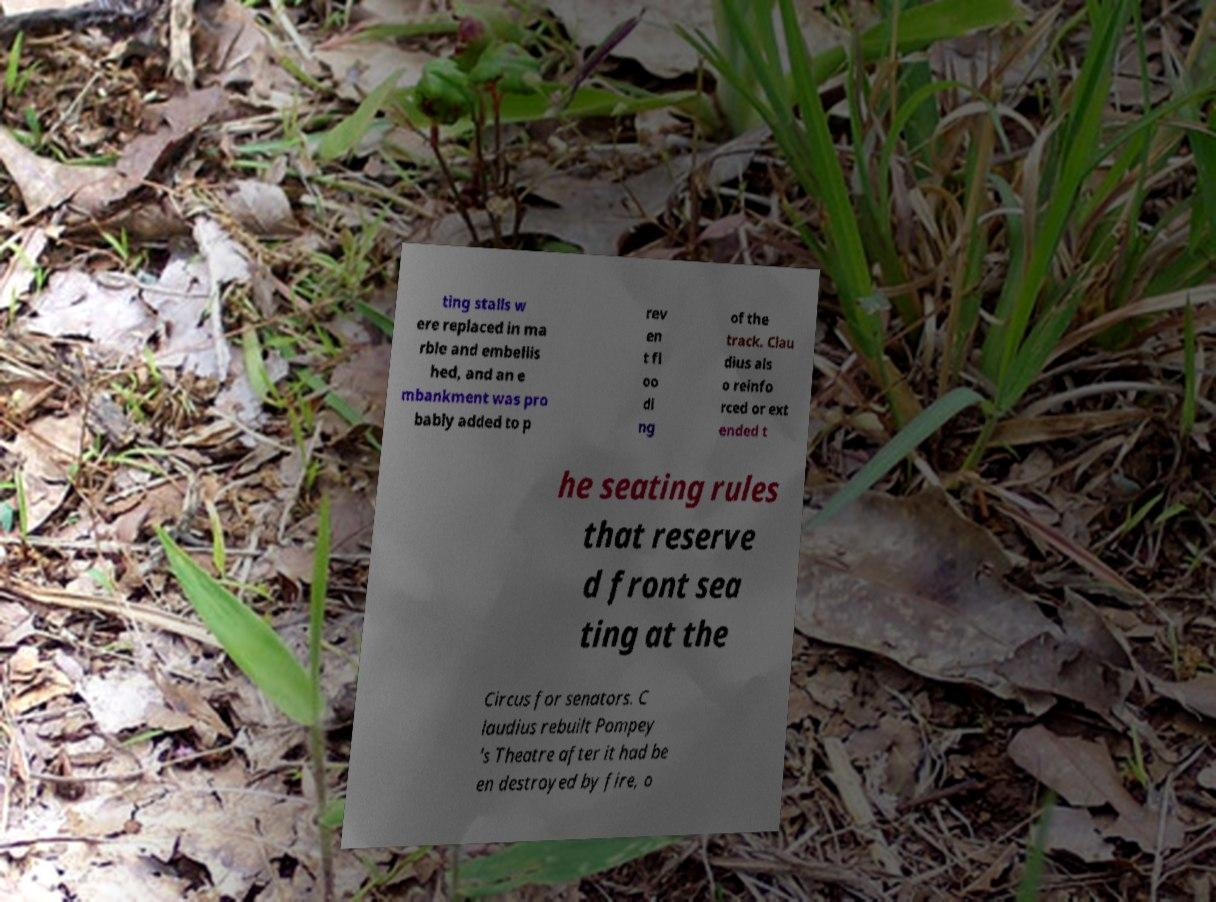I need the written content from this picture converted into text. Can you do that? ting stalls w ere replaced in ma rble and embellis hed, and an e mbankment was pro bably added to p rev en t fl oo di ng of the track. Clau dius als o reinfo rced or ext ended t he seating rules that reserve d front sea ting at the Circus for senators. C laudius rebuilt Pompey 's Theatre after it had be en destroyed by fire, o 